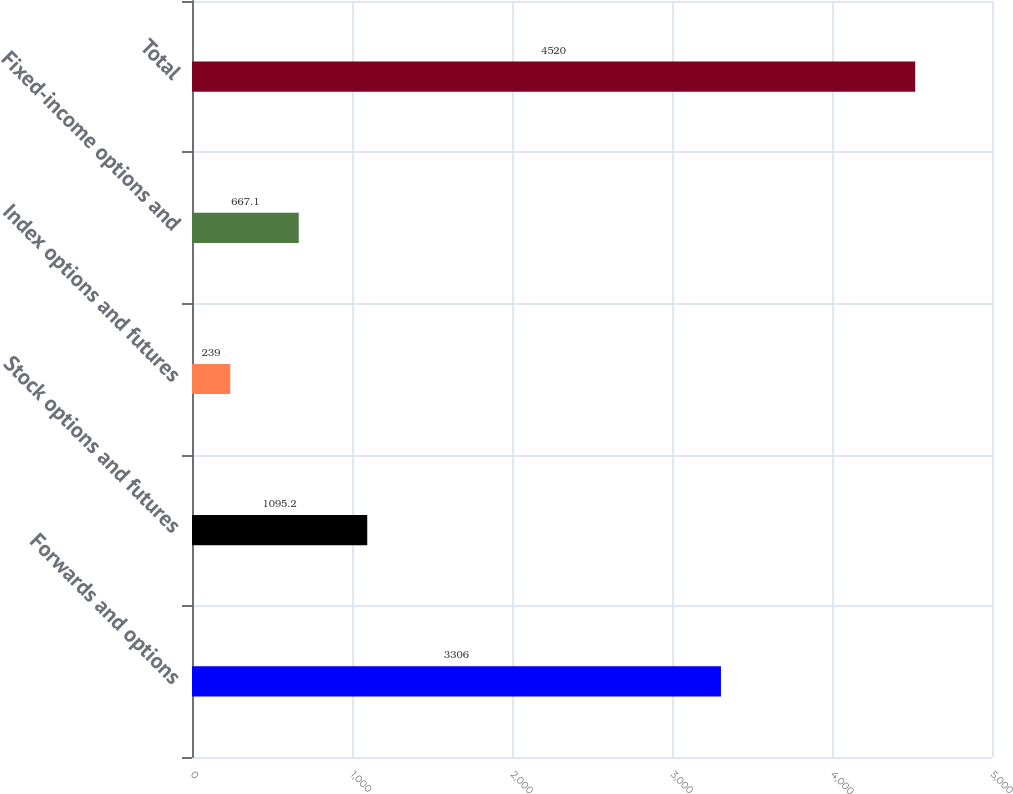Convert chart. <chart><loc_0><loc_0><loc_500><loc_500><bar_chart><fcel>Forwards and options<fcel>Stock options and futures<fcel>Index options and futures<fcel>Fixed-income options and<fcel>Total<nl><fcel>3306<fcel>1095.2<fcel>239<fcel>667.1<fcel>4520<nl></chart> 